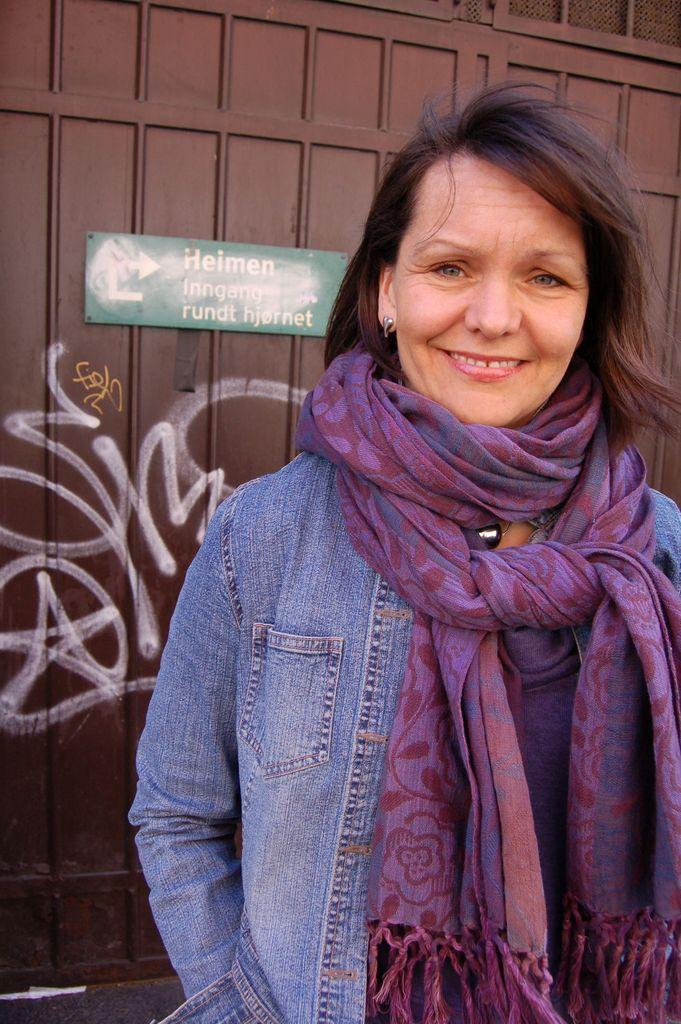Who is present in the image? There is a woman in the image. What is the woman's facial expression? The woman is smiling. What can be seen behind the woman? There is a board visible behind the woman. What is the drawing on? There is a drawing on a metal object in the image. What type of material is present in the image? There is mesh in the image. What type of agreement is being discussed in the image? There is no indication of an agreement being discussed in the image; it primarily features a woman, a board, a drawing, and mesh. How many hens are visible in the image? There are no hens present in the image. 